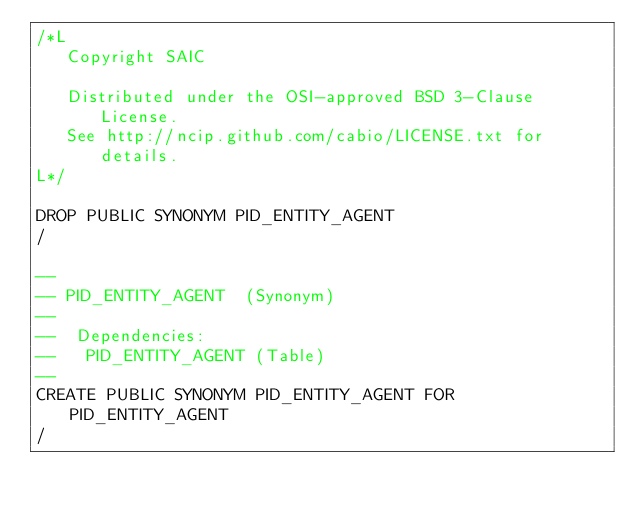Convert code to text. <code><loc_0><loc_0><loc_500><loc_500><_SQL_>/*L
   Copyright SAIC

   Distributed under the OSI-approved BSD 3-Clause License.
   See http://ncip.github.com/cabio/LICENSE.txt for details.
L*/

DROP PUBLIC SYNONYM PID_ENTITY_AGENT
/

--
-- PID_ENTITY_AGENT  (Synonym) 
--
--  Dependencies: 
--   PID_ENTITY_AGENT (Table)
--
CREATE PUBLIC SYNONYM PID_ENTITY_AGENT FOR PID_ENTITY_AGENT
/


</code> 